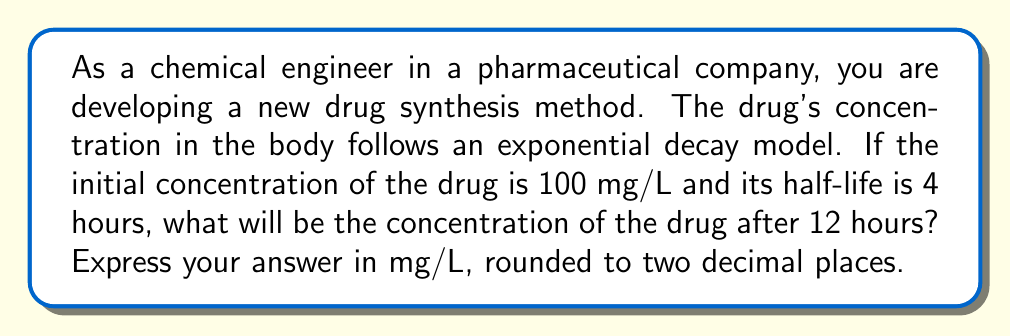Help me with this question. To solve this problem, we'll use the exponential decay formula:

$$C(t) = C_0 \cdot e^{-kt}$$

Where:
$C(t)$ is the concentration at time $t$
$C_0$ is the initial concentration
$k$ is the decay constant
$t$ is the time elapsed

1. We're given:
   $C_0 = 100$ mg/L
   Half-life = 4 hours
   $t = 12$ hours

2. First, we need to find the decay constant $k$ using the half-life formula:

   $$t_{1/2} = \frac{\ln(2)}{k}$$

   Rearranging for $k$:
   $$k = \frac{\ln(2)}{t_{1/2}} = \frac{\ln(2)}{4} = 0.1733$$

3. Now we can substitute all values into the exponential decay formula:

   $$C(12) = 100 \cdot e^{-0.1733 \cdot 12}$$

4. Simplify:
   $$C(12) = 100 \cdot e^{-2.0796}$$
   $$C(12) = 100 \cdot 0.1250$$
   $$C(12) = 12.50$$ mg/L

Therefore, after 12 hours, the concentration of the drug will be 12.50 mg/L.
Answer: 12.50 mg/L 